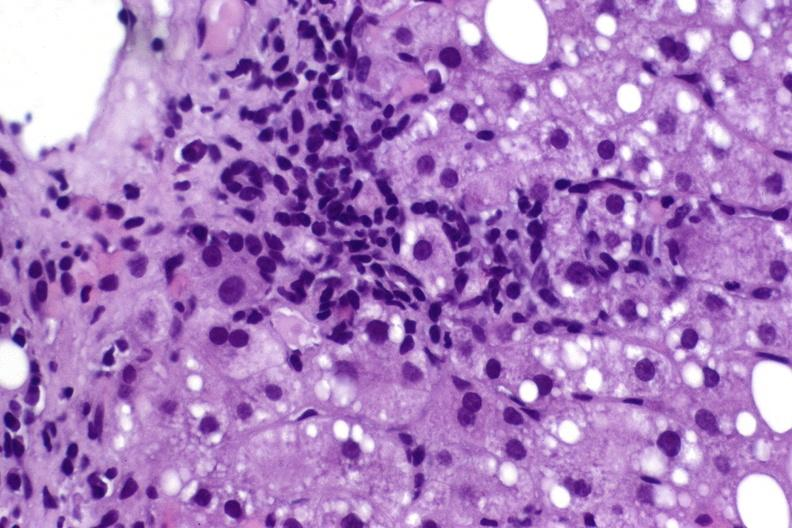does adenoma sebaceum show hepatitis c virus?
Answer the question using a single word or phrase. No 